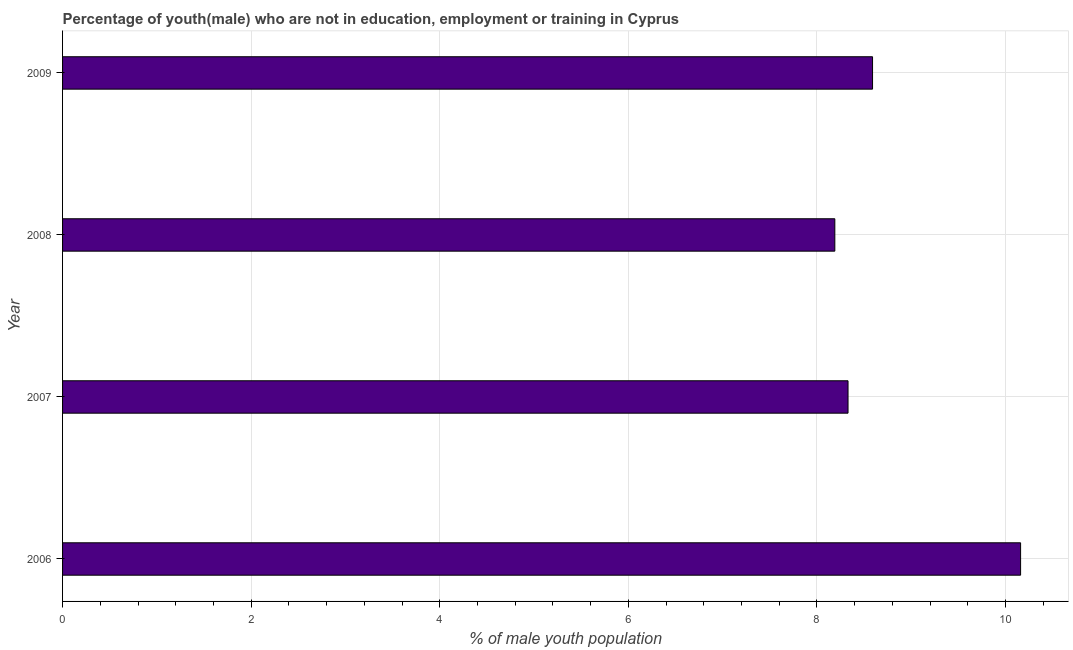Does the graph contain grids?
Give a very brief answer. Yes. What is the title of the graph?
Your answer should be compact. Percentage of youth(male) who are not in education, employment or training in Cyprus. What is the label or title of the X-axis?
Your answer should be compact. % of male youth population. What is the label or title of the Y-axis?
Your response must be concise. Year. What is the unemployed male youth population in 2009?
Your answer should be compact. 8.59. Across all years, what is the maximum unemployed male youth population?
Ensure brevity in your answer.  10.16. Across all years, what is the minimum unemployed male youth population?
Offer a terse response. 8.19. In which year was the unemployed male youth population maximum?
Your answer should be compact. 2006. What is the sum of the unemployed male youth population?
Your answer should be very brief. 35.27. What is the difference between the unemployed male youth population in 2006 and 2009?
Keep it short and to the point. 1.57. What is the average unemployed male youth population per year?
Your answer should be very brief. 8.82. What is the median unemployed male youth population?
Give a very brief answer. 8.46. Do a majority of the years between 2008 and 2007 (inclusive) have unemployed male youth population greater than 2.8 %?
Your answer should be compact. No. What is the difference between the highest and the second highest unemployed male youth population?
Your answer should be compact. 1.57. Is the sum of the unemployed male youth population in 2007 and 2009 greater than the maximum unemployed male youth population across all years?
Provide a short and direct response. Yes. What is the difference between the highest and the lowest unemployed male youth population?
Provide a succinct answer. 1.97. In how many years, is the unemployed male youth population greater than the average unemployed male youth population taken over all years?
Offer a very short reply. 1. Are all the bars in the graph horizontal?
Keep it short and to the point. Yes. How many years are there in the graph?
Give a very brief answer. 4. What is the % of male youth population in 2006?
Provide a short and direct response. 10.16. What is the % of male youth population in 2007?
Ensure brevity in your answer.  8.33. What is the % of male youth population in 2008?
Offer a terse response. 8.19. What is the % of male youth population in 2009?
Your answer should be very brief. 8.59. What is the difference between the % of male youth population in 2006 and 2007?
Make the answer very short. 1.83. What is the difference between the % of male youth population in 2006 and 2008?
Give a very brief answer. 1.97. What is the difference between the % of male youth population in 2006 and 2009?
Your answer should be very brief. 1.57. What is the difference between the % of male youth population in 2007 and 2008?
Your response must be concise. 0.14. What is the difference between the % of male youth population in 2007 and 2009?
Make the answer very short. -0.26. What is the ratio of the % of male youth population in 2006 to that in 2007?
Provide a short and direct response. 1.22. What is the ratio of the % of male youth population in 2006 to that in 2008?
Give a very brief answer. 1.24. What is the ratio of the % of male youth population in 2006 to that in 2009?
Your response must be concise. 1.18. What is the ratio of the % of male youth population in 2008 to that in 2009?
Give a very brief answer. 0.95. 